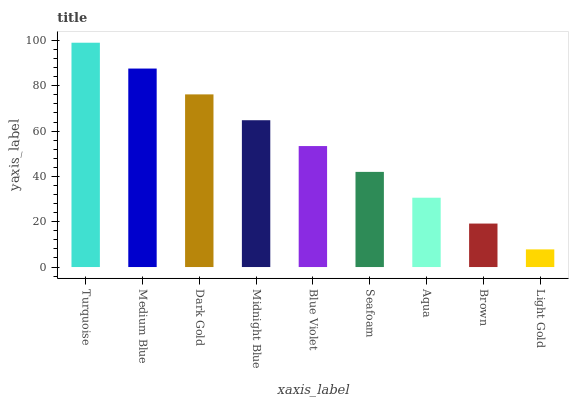Is Medium Blue the minimum?
Answer yes or no. No. Is Medium Blue the maximum?
Answer yes or no. No. Is Turquoise greater than Medium Blue?
Answer yes or no. Yes. Is Medium Blue less than Turquoise?
Answer yes or no. Yes. Is Medium Blue greater than Turquoise?
Answer yes or no. No. Is Turquoise less than Medium Blue?
Answer yes or no. No. Is Blue Violet the high median?
Answer yes or no. Yes. Is Blue Violet the low median?
Answer yes or no. Yes. Is Light Gold the high median?
Answer yes or no. No. Is Turquoise the low median?
Answer yes or no. No. 